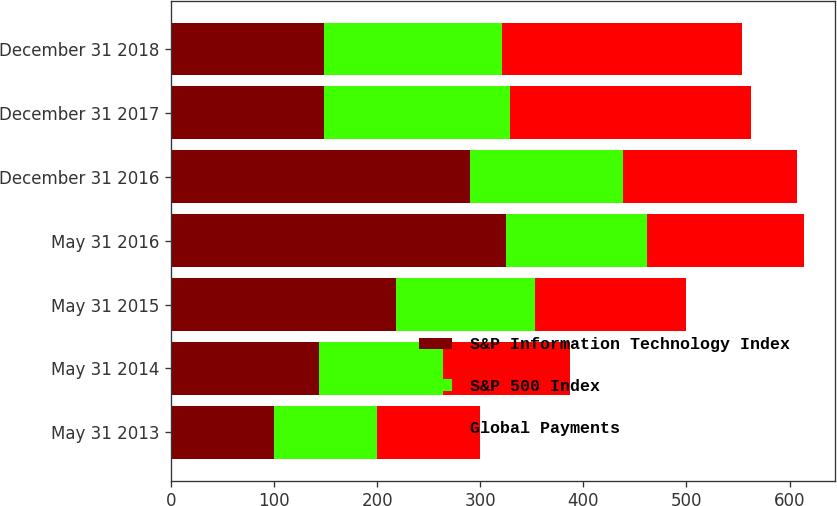Convert chart to OTSL. <chart><loc_0><loc_0><loc_500><loc_500><stacked_bar_chart><ecel><fcel>May 31 2013<fcel>May 31 2014<fcel>May 31 2015<fcel>May 31 2016<fcel>December 31 2016<fcel>December 31 2017<fcel>December 31 2018<nl><fcel>S&P Information Technology Index<fcel>100<fcel>143.14<fcel>218.13<fcel>324.92<fcel>290.37<fcel>148.08<fcel>148.08<nl><fcel>S&P 500 Index<fcel>100<fcel>120.45<fcel>134.67<fcel>136.98<fcel>148.08<fcel>180.41<fcel>172.5<nl><fcel>Global Payments<fcel>100<fcel>123.89<fcel>147.2<fcel>151.8<fcel>168.59<fcel>234.05<fcel>233.38<nl></chart> 